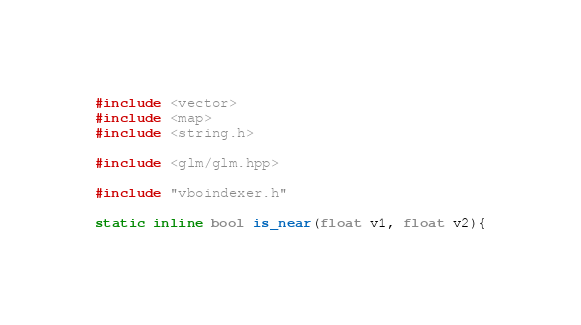<code> <loc_0><loc_0><loc_500><loc_500><_C++_>#include <vector>
#include <map>
#include <string.h>

#include <glm/glm.hpp>

#include "vboindexer.h"

static inline bool is_near(float v1, float v2){</code> 